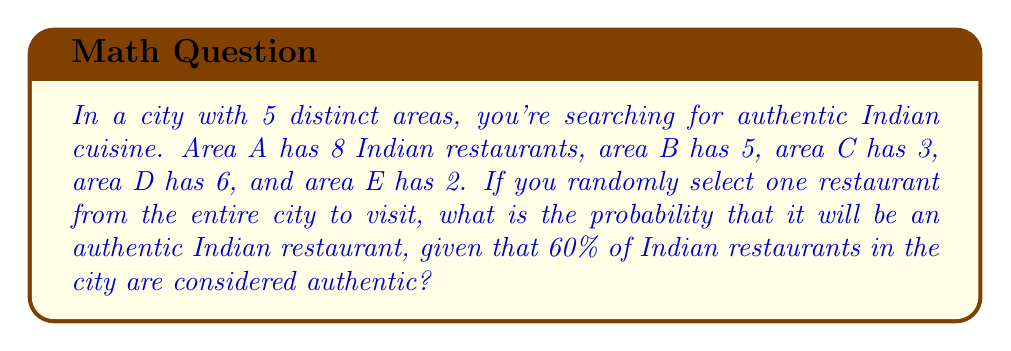Can you solve this math problem? Let's approach this step-by-step:

1) First, let's calculate the total number of Indian restaurants in the city:
   $$ 8 + 5 + 3 + 6 + 2 = 24 $$

2) We're told that 60% of these are authentic. To find the number of authentic restaurants:
   $$ 24 \times 0.60 = 14.4 $$
   Since we can't have a fractional restaurant, we round down to 14 authentic Indian restaurants.

3) Now, we need to find the total number of restaurants in the city. Let's assume that Indian restaurants make up 20% of all restaurants in the city. We can set up an equation:
   $$ 24 = 0.20x $$
   Where $x$ is the total number of restaurants.

4) Solving for $x$:
   $$ x = \frac{24}{0.20} = 120 $$

5) Now we can calculate the probability. The probability is the number of favorable outcomes divided by the total number of possible outcomes:

   $$ P(\text{authentic Indian}) = \frac{\text{number of authentic Indian restaurants}}{\text{total number of restaurants}} $$

   $$ P(\text{authentic Indian}) = \frac{14}{120} = \frac{7}{60} \approx 0.1167 $$
Answer: $\frac{7}{60}$ or approximately $0.1167$ or $11.67\%$ 